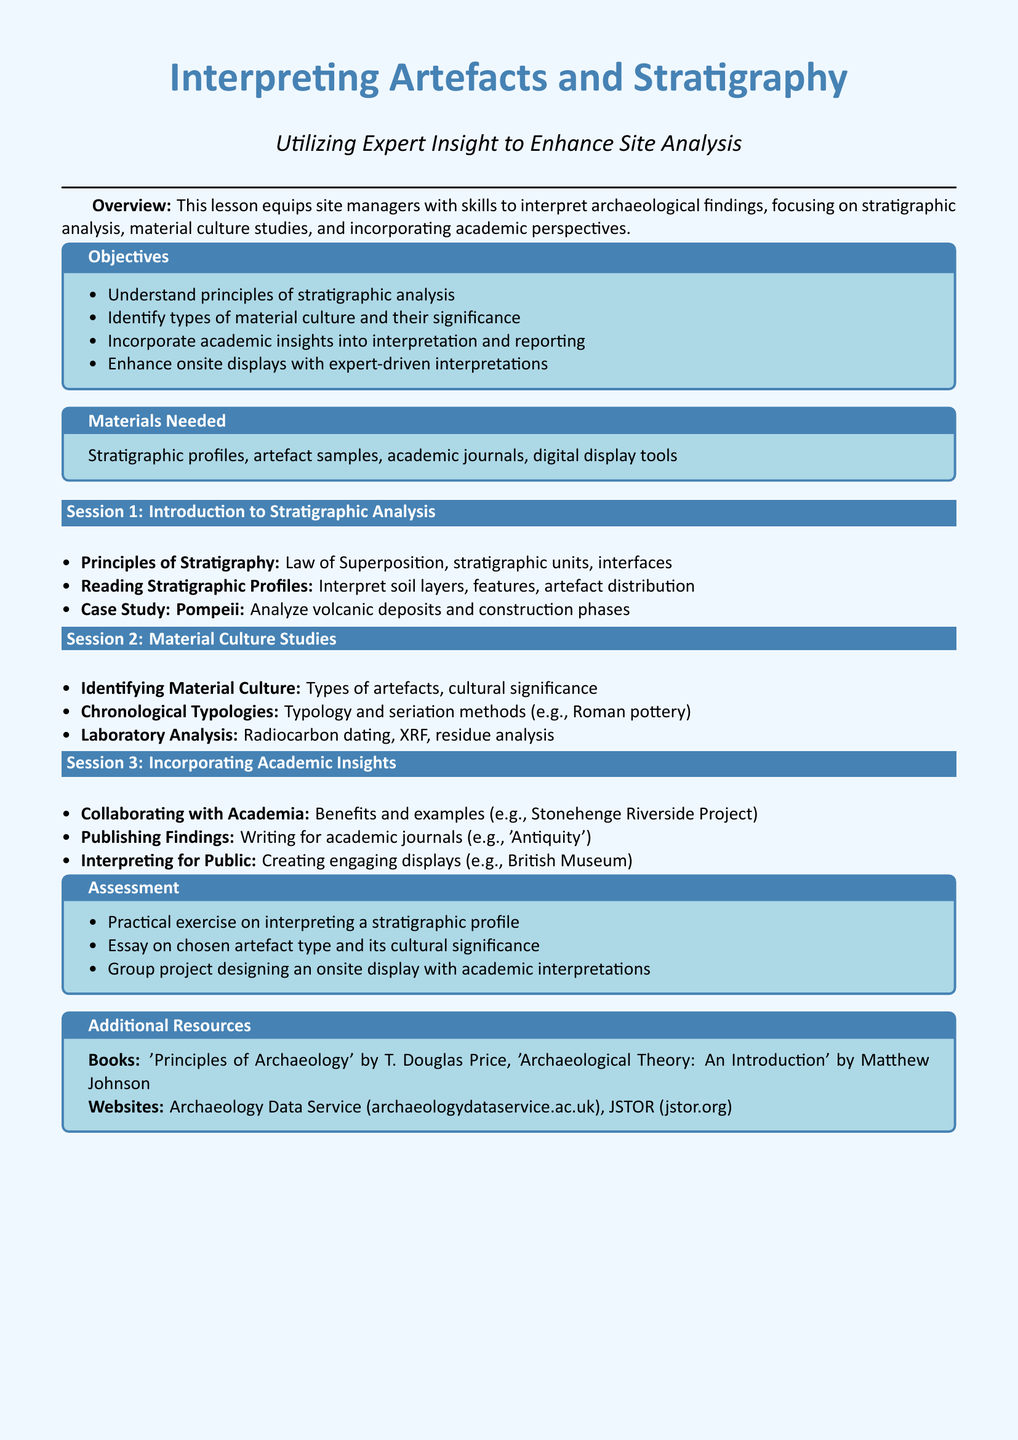What are the lesson objectives? The lesson objectives outline the key skills and knowledge that site managers will gain from the lesson, including understanding stratigraphic analysis and incorporating academic insights.
Answer: Understand principles of stratigraphic analysis, Identify types of material culture and their significance, Incorporate academic insights into interpretation and reporting, Enhance onsite displays with expert-driven interpretations What is included in the materials needed? The materials needed list essential tools and resources required for the lesson, including stratigraphic profiles and artefact samples.
Answer: Stratigraphic profiles, artefact samples, academic journals, digital display tools Name one principle of stratigraphic analysis discussed. The document specifies particular principles associated with stratigraphic analysis, such as the Law of Superposition.
Answer: Law of Superposition What is a type of artefact mentioned in session 2? The lesson plan details specific types of artefacts that will be discussed, including examples like Roman pottery.
Answer: Roman pottery What is an example of a collaborative project mentioned? The document provides an example of a project that showcases the benefits of collaboration with academia, specifically the Stonehenge Riverside Project.
Answer: Stonehenge Riverside Project What type of practical exercise is included in the assessment? The assessment section outlines various tasks to evaluate the learners, including a practical exercise that focuses on interpreting stratigraphic profiles.
Answer: Interpreting a stratigraphic profile What is one additional resource mentioned in the document? The additional resources section lists further reading and websites that can enhance understanding, such as the Archaeology Data Service.
Answer: Archaeology Data Service 